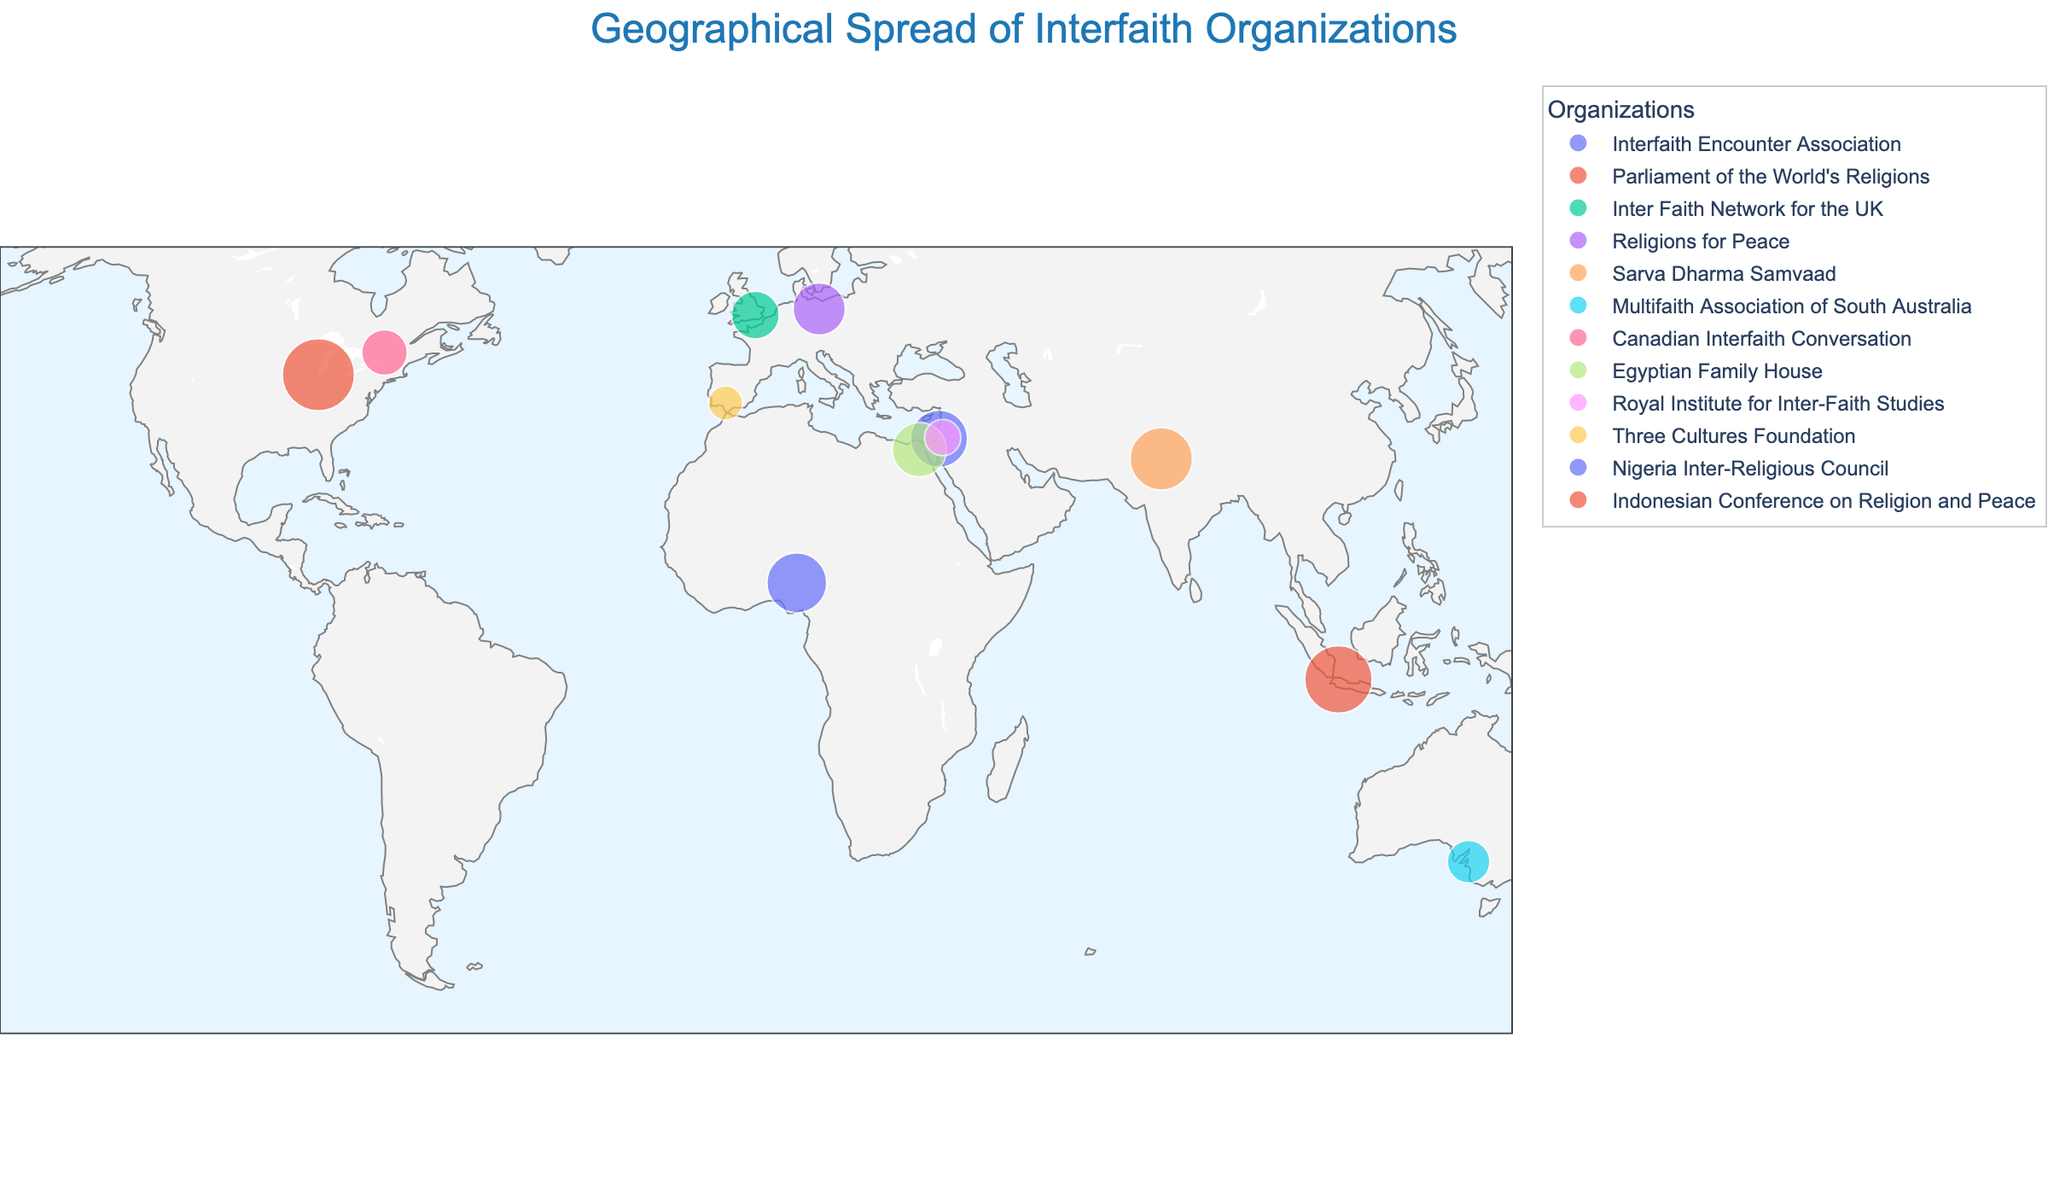What is the title of the figure? The title of the figure is displayed prominently at the top.
Answer: Geographical Spread of Interfaith Organizations How many organizations are shown on the map? By visually counting the different colored points representing each organization, we see there are 12 organizations.
Answer: 12 Which country has the largest interfaith organization in terms of members? By looking at the size of the circles on the map, the largest circle represents the "Parliament of the World's Religions" in the United States with 8,000 members.
Answer: United States What is the latitude and longitude of the Interfaith Encounter Association? By hovering over or looking at the point labeled "Israel," we find its latitude and longitude.
Answer: 31.7683, 35.2137 Which organization is located furthest south according to the map? The organization with the point closest to the bottom of the map (southern hemisphere) is "Multifaith Association of South Australia" in Australia.
Answer: Multifaith Association of South Australia Compare the number of members in the Three Cultures Foundation and Nigerian Inter-Religious Council. Which one has more members? By comparing the sizes of the circles, we see that the Nigerian Inter-Religious Council has 5,500 members, and the Three Cultures Foundation has 1,800 members. Therefore, the Nigerian Inter-Religious Council has more members.
Answer: Nigerian Inter-Religious Council What is the total number of members for all organizations depicted on the map? To find the total, sum up the members of all organizations: 5000 + 8000 + 3500 + 4200 + 6000 + 2800 + 3200 + 4500 + 2000 + 1800 + 5500 + 7000 = 53,500 members.
Answer: 53,500 Which continent hosts the most interfaith organizations according to the map? By visually grouping the points (organizations) on the map by continent, Europe hosts the most with organizations in the United Kingdom, Germany, and Spain.
Answer: Europe What is the median number of members among these organizations? To find the median, list all members in ascending order: 1800, 2000, 2800, 3200, 3500, 4200, 4500, 5000, 5500, 6000, 7000, 8000. The median is the average of the 6th and 7th values, (4200 + 4500)/2 = 4350.
Answer: 4350 